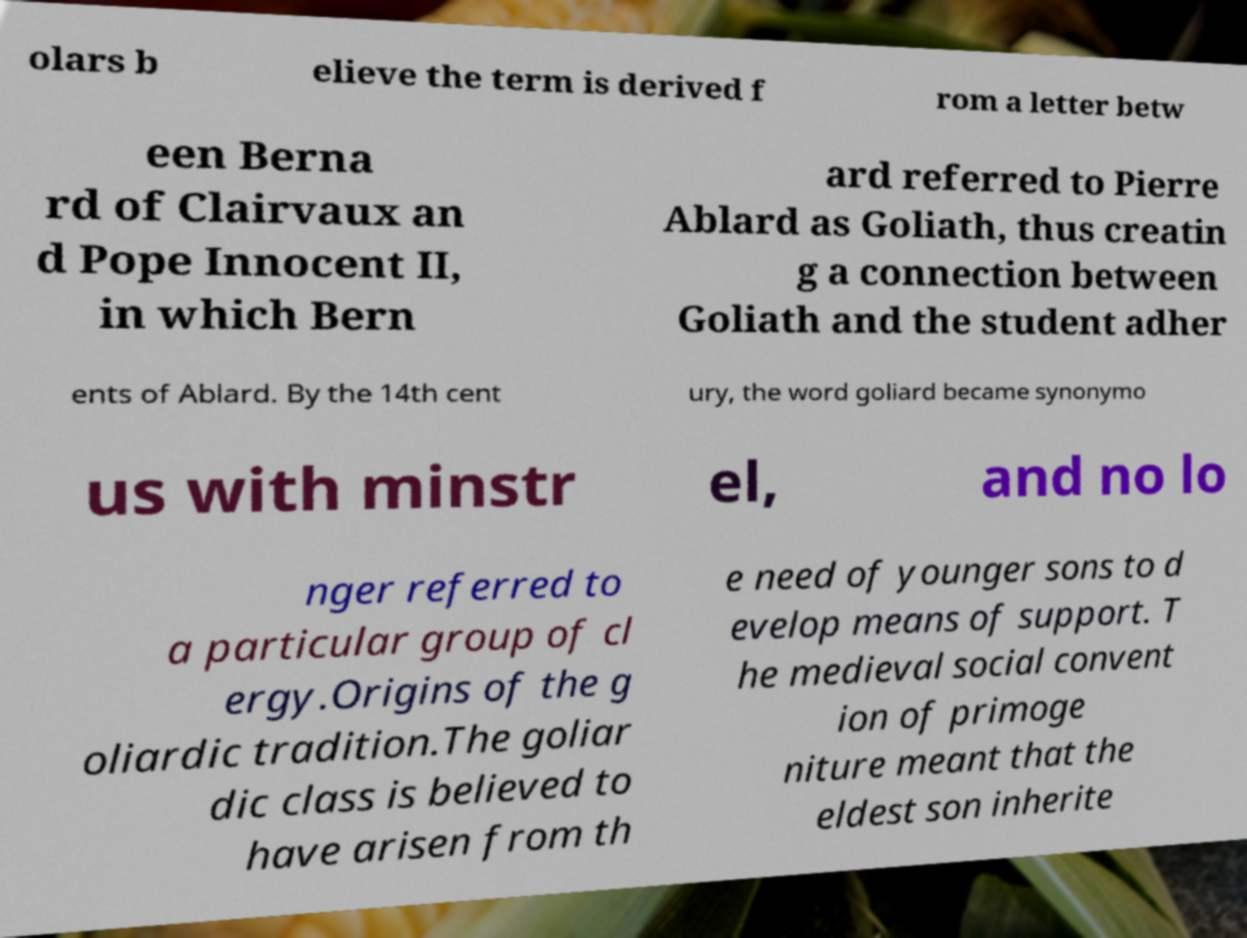Please identify and transcribe the text found in this image. olars b elieve the term is derived f rom a letter betw een Berna rd of Clairvaux an d Pope Innocent II, in which Bern ard referred to Pierre Ablard as Goliath, thus creatin g a connection between Goliath and the student adher ents of Ablard. By the 14th cent ury, the word goliard became synonymo us with minstr el, and no lo nger referred to a particular group of cl ergy.Origins of the g oliardic tradition.The goliar dic class is believed to have arisen from th e need of younger sons to d evelop means of support. T he medieval social convent ion of primoge niture meant that the eldest son inherite 